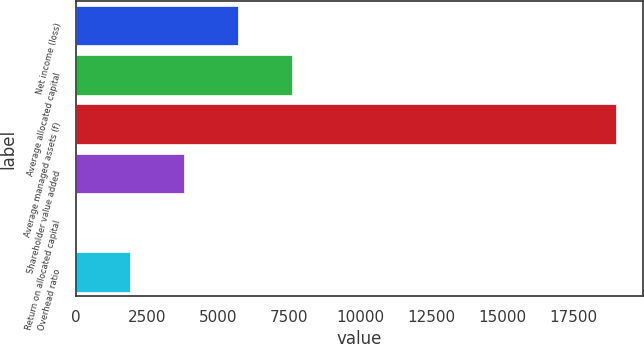<chart> <loc_0><loc_0><loc_500><loc_500><bar_chart><fcel>Net income (loss)<fcel>Average allocated capital<fcel>Average managed assets (f)<fcel>Shareholder value added<fcel>Return on allocated capital<fcel>Overhead ratio<nl><fcel>5711.2<fcel>7608.6<fcel>18993<fcel>3813.8<fcel>19<fcel>1916.4<nl></chart> 